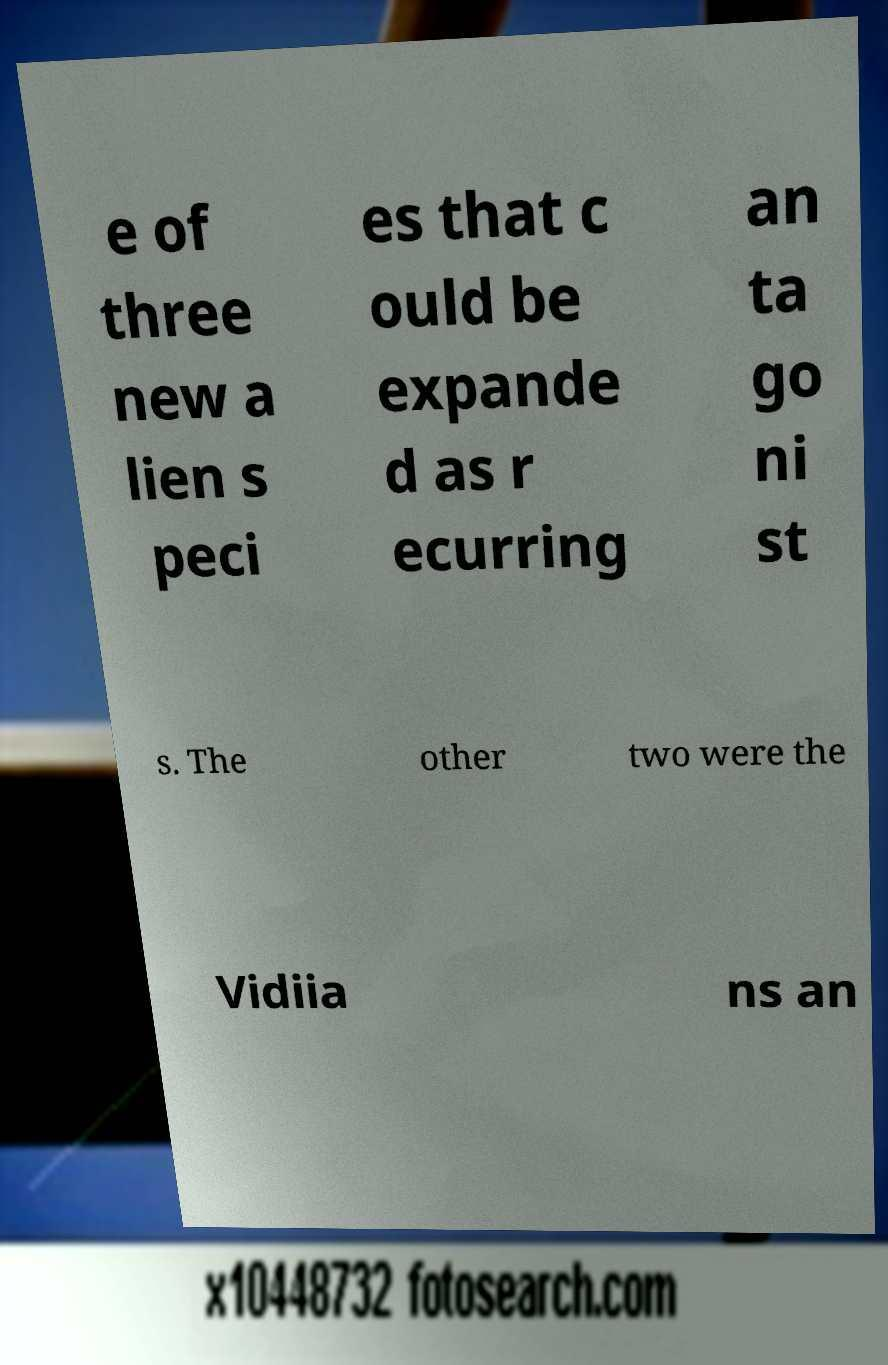Can you read and provide the text displayed in the image?This photo seems to have some interesting text. Can you extract and type it out for me? e of three new a lien s peci es that c ould be expande d as r ecurring an ta go ni st s. The other two were the Vidiia ns an 